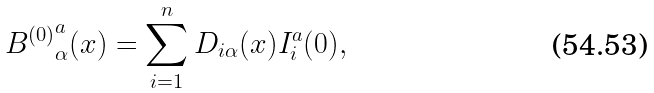<formula> <loc_0><loc_0><loc_500><loc_500>{ B ^ { ( 0 ) } } _ { \alpha } ^ { a } ( x ) = \sum _ { i = 1 } ^ { n } D _ { i \alpha } ( x ) I _ { i } ^ { a } ( 0 ) ,</formula> 